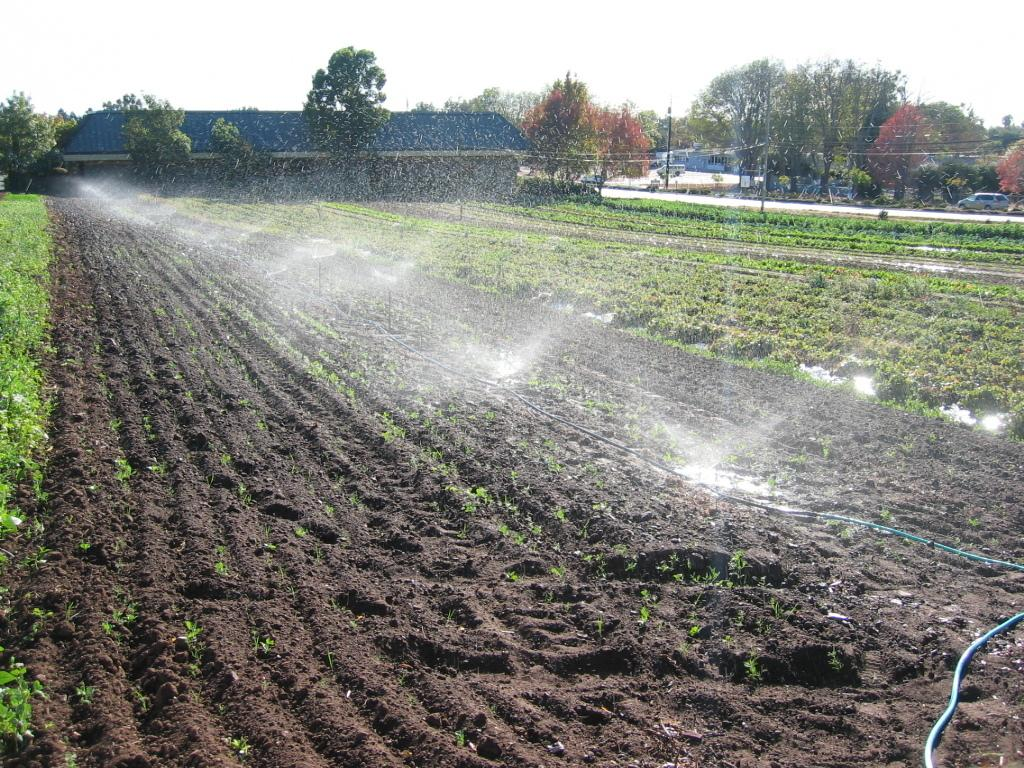What type of land is shown in the image? There is farmland in the image. What can be seen on the farmland? Water sprinklers are present in the farmland. What structures are visible in the background of the image? There is a wooden house and trees in the background of the image? What else can be seen in the background of the image? Vehicles are present on the road and the sky is visible in the background of the image. What type of suit is the farmland wearing in the image? The farmland is not wearing a suit, as it is a piece of land and not a person. 